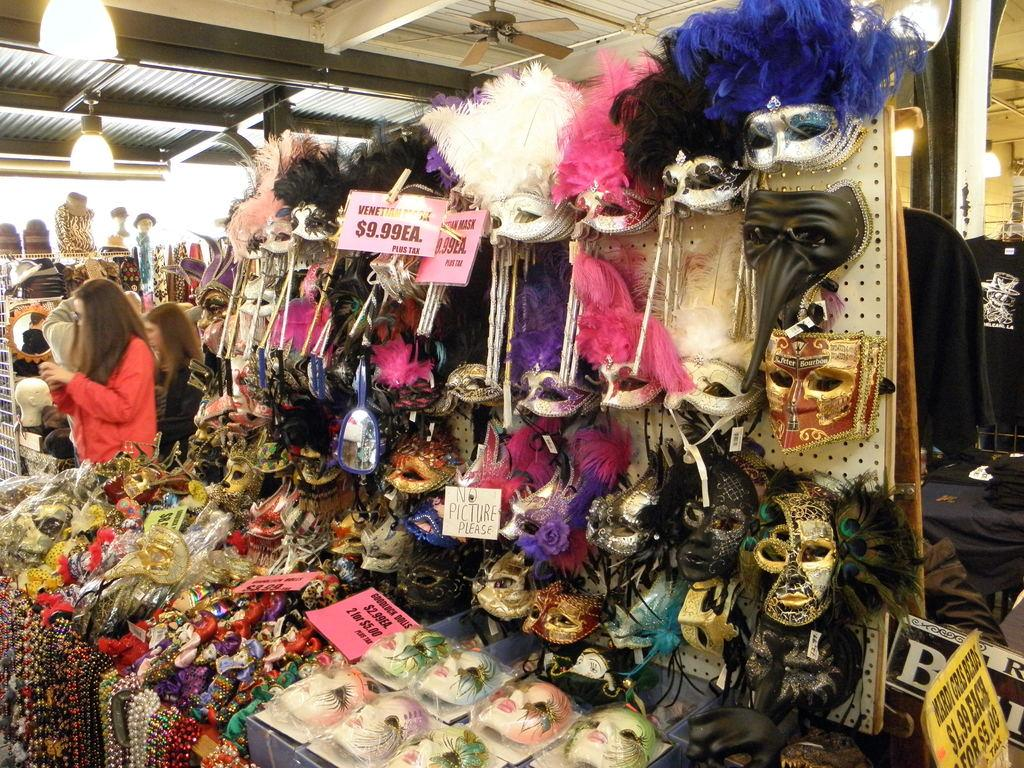What type of establishment is shown in the image? There is a shop in the image. What items can be found in the shop? The shop contains masks and chains. Are there any people present in the shop? Yes, there are people standing in the shop. What architectural feature is visible in the image? There is a roof visible in the image. What type of lighting is present in the shop? There are lights in the image. What device can be seen for circulating air? There is a fan in the image. What type of art can be seen hanging on the walls in the image? There is no art visible on the walls in the image; it primarily features masks and chains. Is there any oil being used in the image? There is no mention of oil or any related activity in the image. 